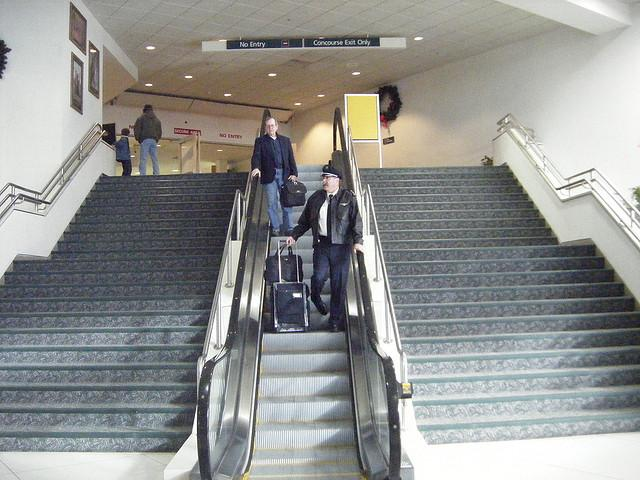Where are the two old men located in? airport 